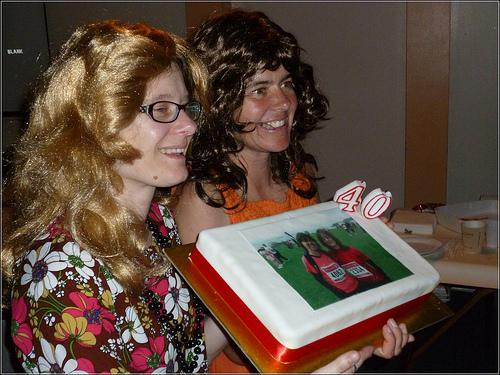Question: how many people are there?
Choices:
A. Two.
B. One.
C. Three.
D. Four.
Answer with the letter. Answer: A Question: what are the people holding?
Choices:
A. A drink.
B. Toys.
C. A cake.
D. Balloons.
Answer with the letter. Answer: C Question: who is wearing the glasses?
Choices:
A. The old man.
B. The child.
C. The clown.
D. The person on the left.
Answer with the letter. Answer: D Question: what are the people doing with their mouths?
Choices:
A. Blowing bubbles.
B. Talking.
C. Chewing gum.
D. Smiling.
Answer with the letter. Answer: D 